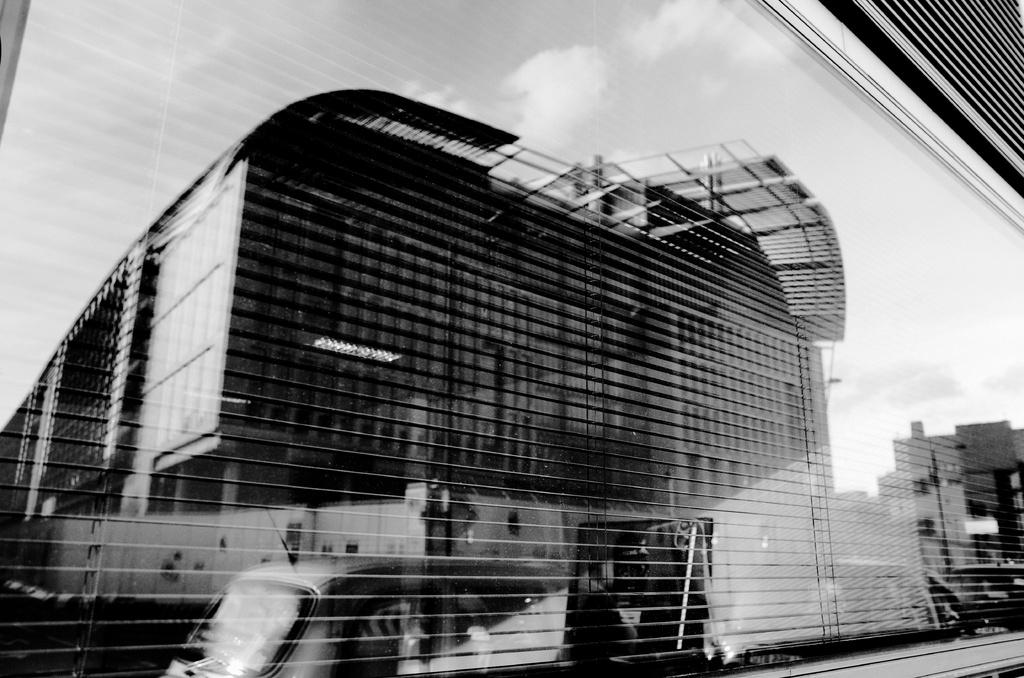What is the color scheme of the image? The image is black and white. What type of structures can be seen in the image? There are buildings in the image. What part of the natural environment is visible in the image? The sky is visible in the image. What mode of transportation is present in the image? There is a vehicle in the image. Can you describe any interesting visual effects in the image? It appears that there is a reflection on a glass surface in the image. What type of car is being offered for sale in the image? There is no car present in the image, and no offer is being made. How many bricks are visible in the image? There is no mention of bricks in the image, so it is not possible to determine how many are visible. 